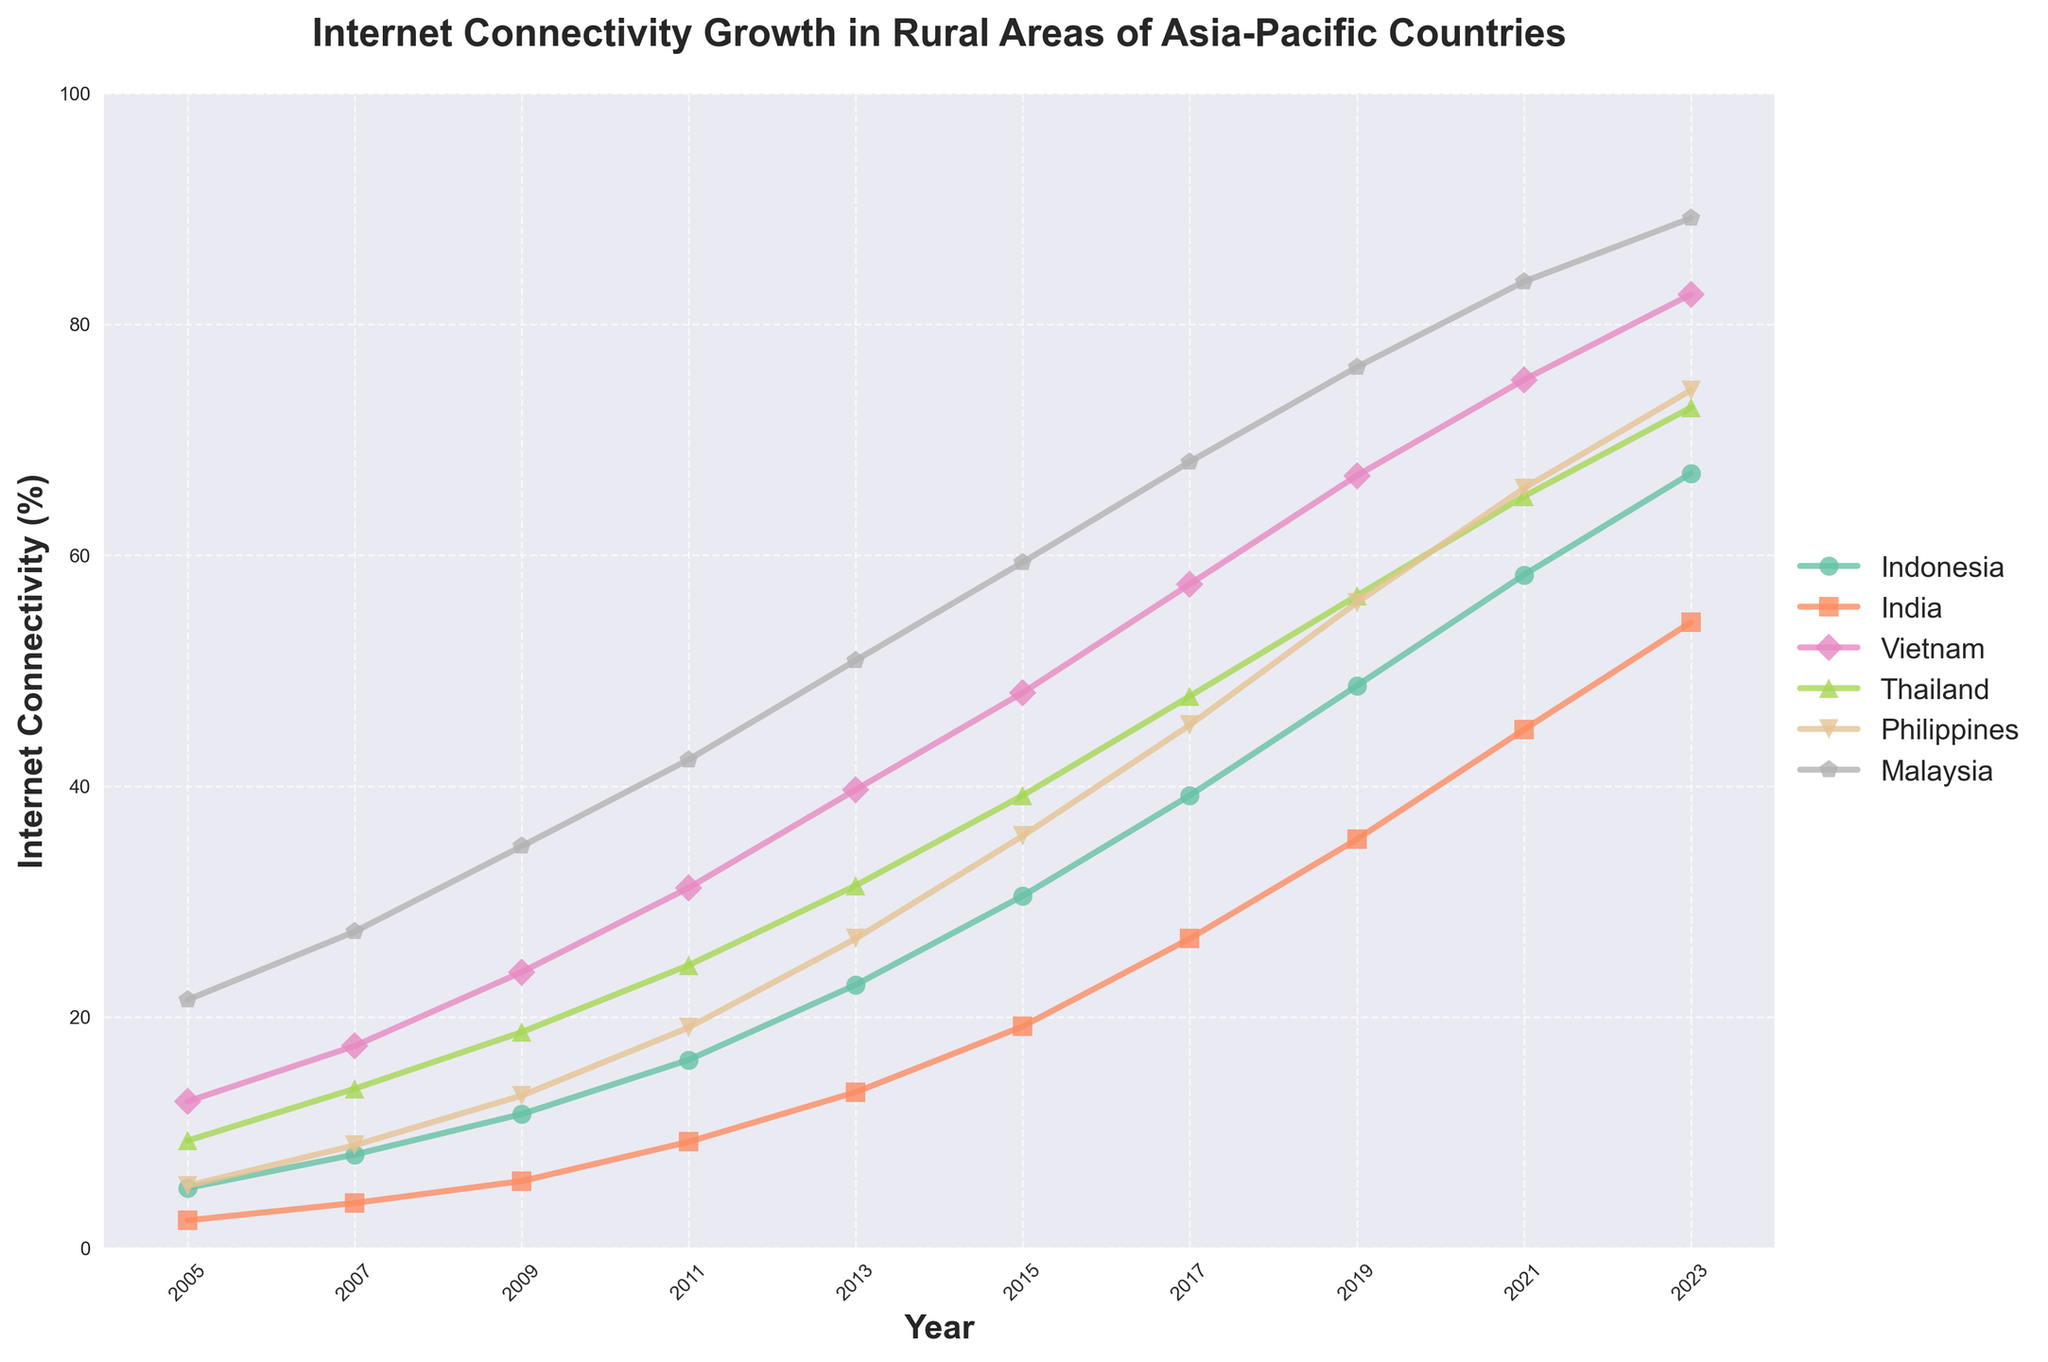What was the increase in internet connectivity percentage in rural Indonesia between 2005 and 2011? To find the increase, subtract the percentage in 2005 from the percentage in 2011 (16.3 - 5.2 = 11.1).
Answer: 11.1 Which country had the highest internet connectivity percentage in 2023? Look at the percentages for each country in 2023, Malaysia has the highest with 89.2.
Answer: Malaysia How much higher was the internet connectivity percentage in rural areas of Vietnam in 2015 compared to India in the same year? Subtract India's percentage in 2015 from Vietnam's percentage in 2015 (48.1 - 19.2 = 28.9).
Answer: 28.9 In 2017, how did the internet connectivity percentage in the Philippines compare to Thailand? Compare the values for both countries in 2017, with Philippines at 45.3% and Thailand at 47.8%. Philippines is 2.5% lower than Thailand.
Answer: Philippines had 2.5% less On average, how much did the internet connectivity percentage in rural Malaysia grow annually from 2005 to 2023? Calculate the total increase (89.2 - 21.5 = 67.7) and divide by the number of years (2023 - 2005 = 18); 67.7 / 18 = 3.76.
Answer: 3.76 per year Between 2005 and 2015, which country showed the fastest growth in internet connectivity percentage? Compare the differences in percentages for each country between 2005 and 2015. Vietnam had the fastest growth (48.1 - 12.7 = 35.4).
Answer: Vietnam What is the trend of internet connectivity growth in rural India from 2005 to 2023, and how does it compare to Indonesia? Observe both trends. Both countries show a consistent upward trend, with India increasing from 2.4% to 54.2%, while Indonesia rises from 5.2% to 67.1%. India grew from a lower base but at a steadier rate.
Answer: Upward trend for both In which year did rural internet connectivity in Thailand first exceed 50%? Look at the data for Thailand year-by-year and find the year when it first goes above 50%, which is 2019 (56.5%).
Answer: 2019 